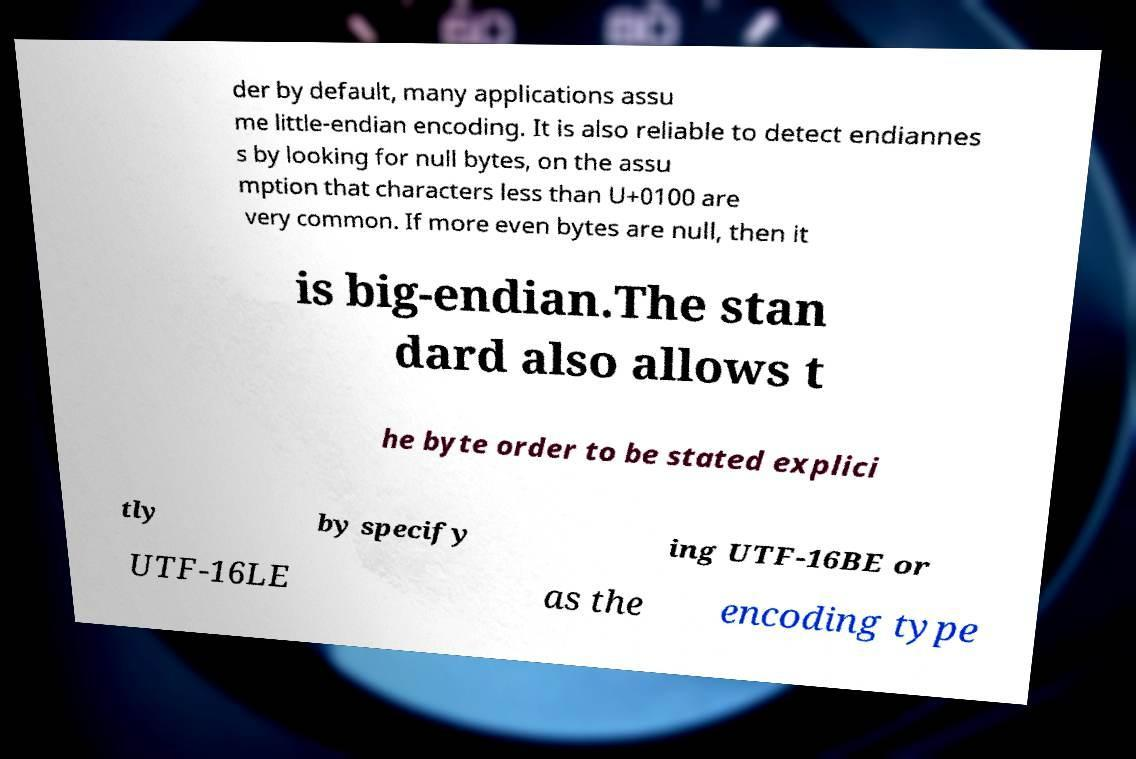What messages or text are displayed in this image? I need them in a readable, typed format. der by default, many applications assu me little-endian encoding. It is also reliable to detect endiannes s by looking for null bytes, on the assu mption that characters less than U+0100 are very common. If more even bytes are null, then it is big-endian.The stan dard also allows t he byte order to be stated explici tly by specify ing UTF-16BE or UTF-16LE as the encoding type 